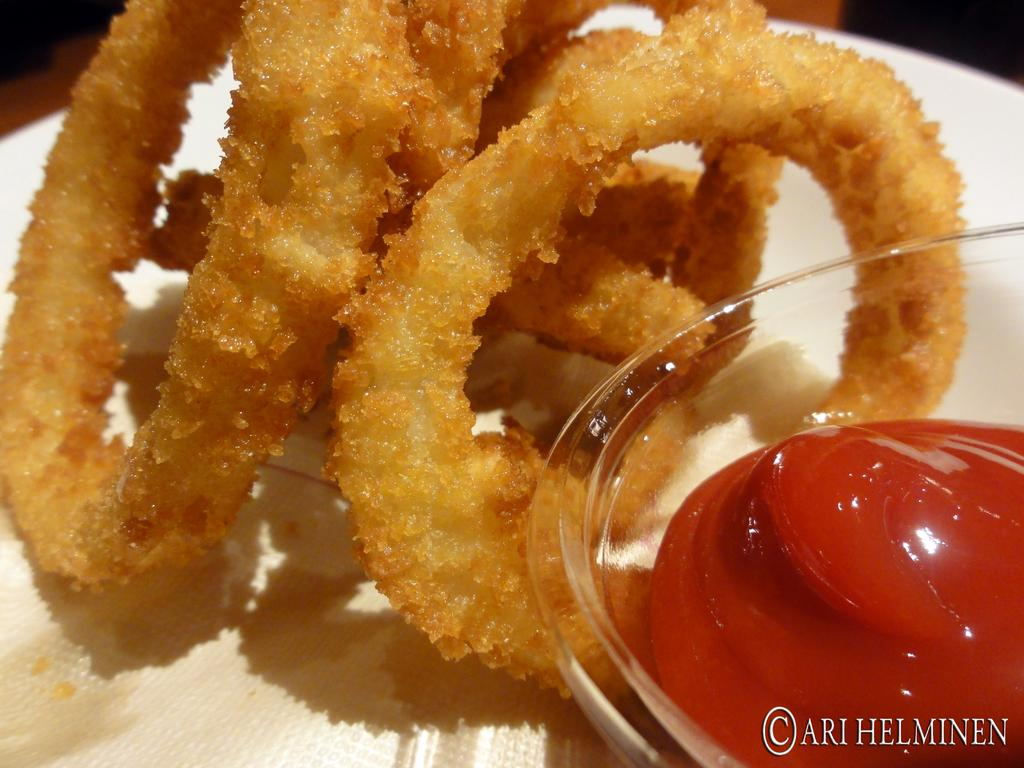What type of container holds the food in the image? The food is in a glass bowl. What else is present in the glass bowl besides the food? There is sauce in the glass bowl. On what type of plate is the glass bowl placed? The food and sauce are on a white color plate. What is the color of the food in the image? The food is in brown color. How much debt does the food owe in the image? There is no mention of debt in the image, as it features food in a glass bowl with sauce on a white plate. 